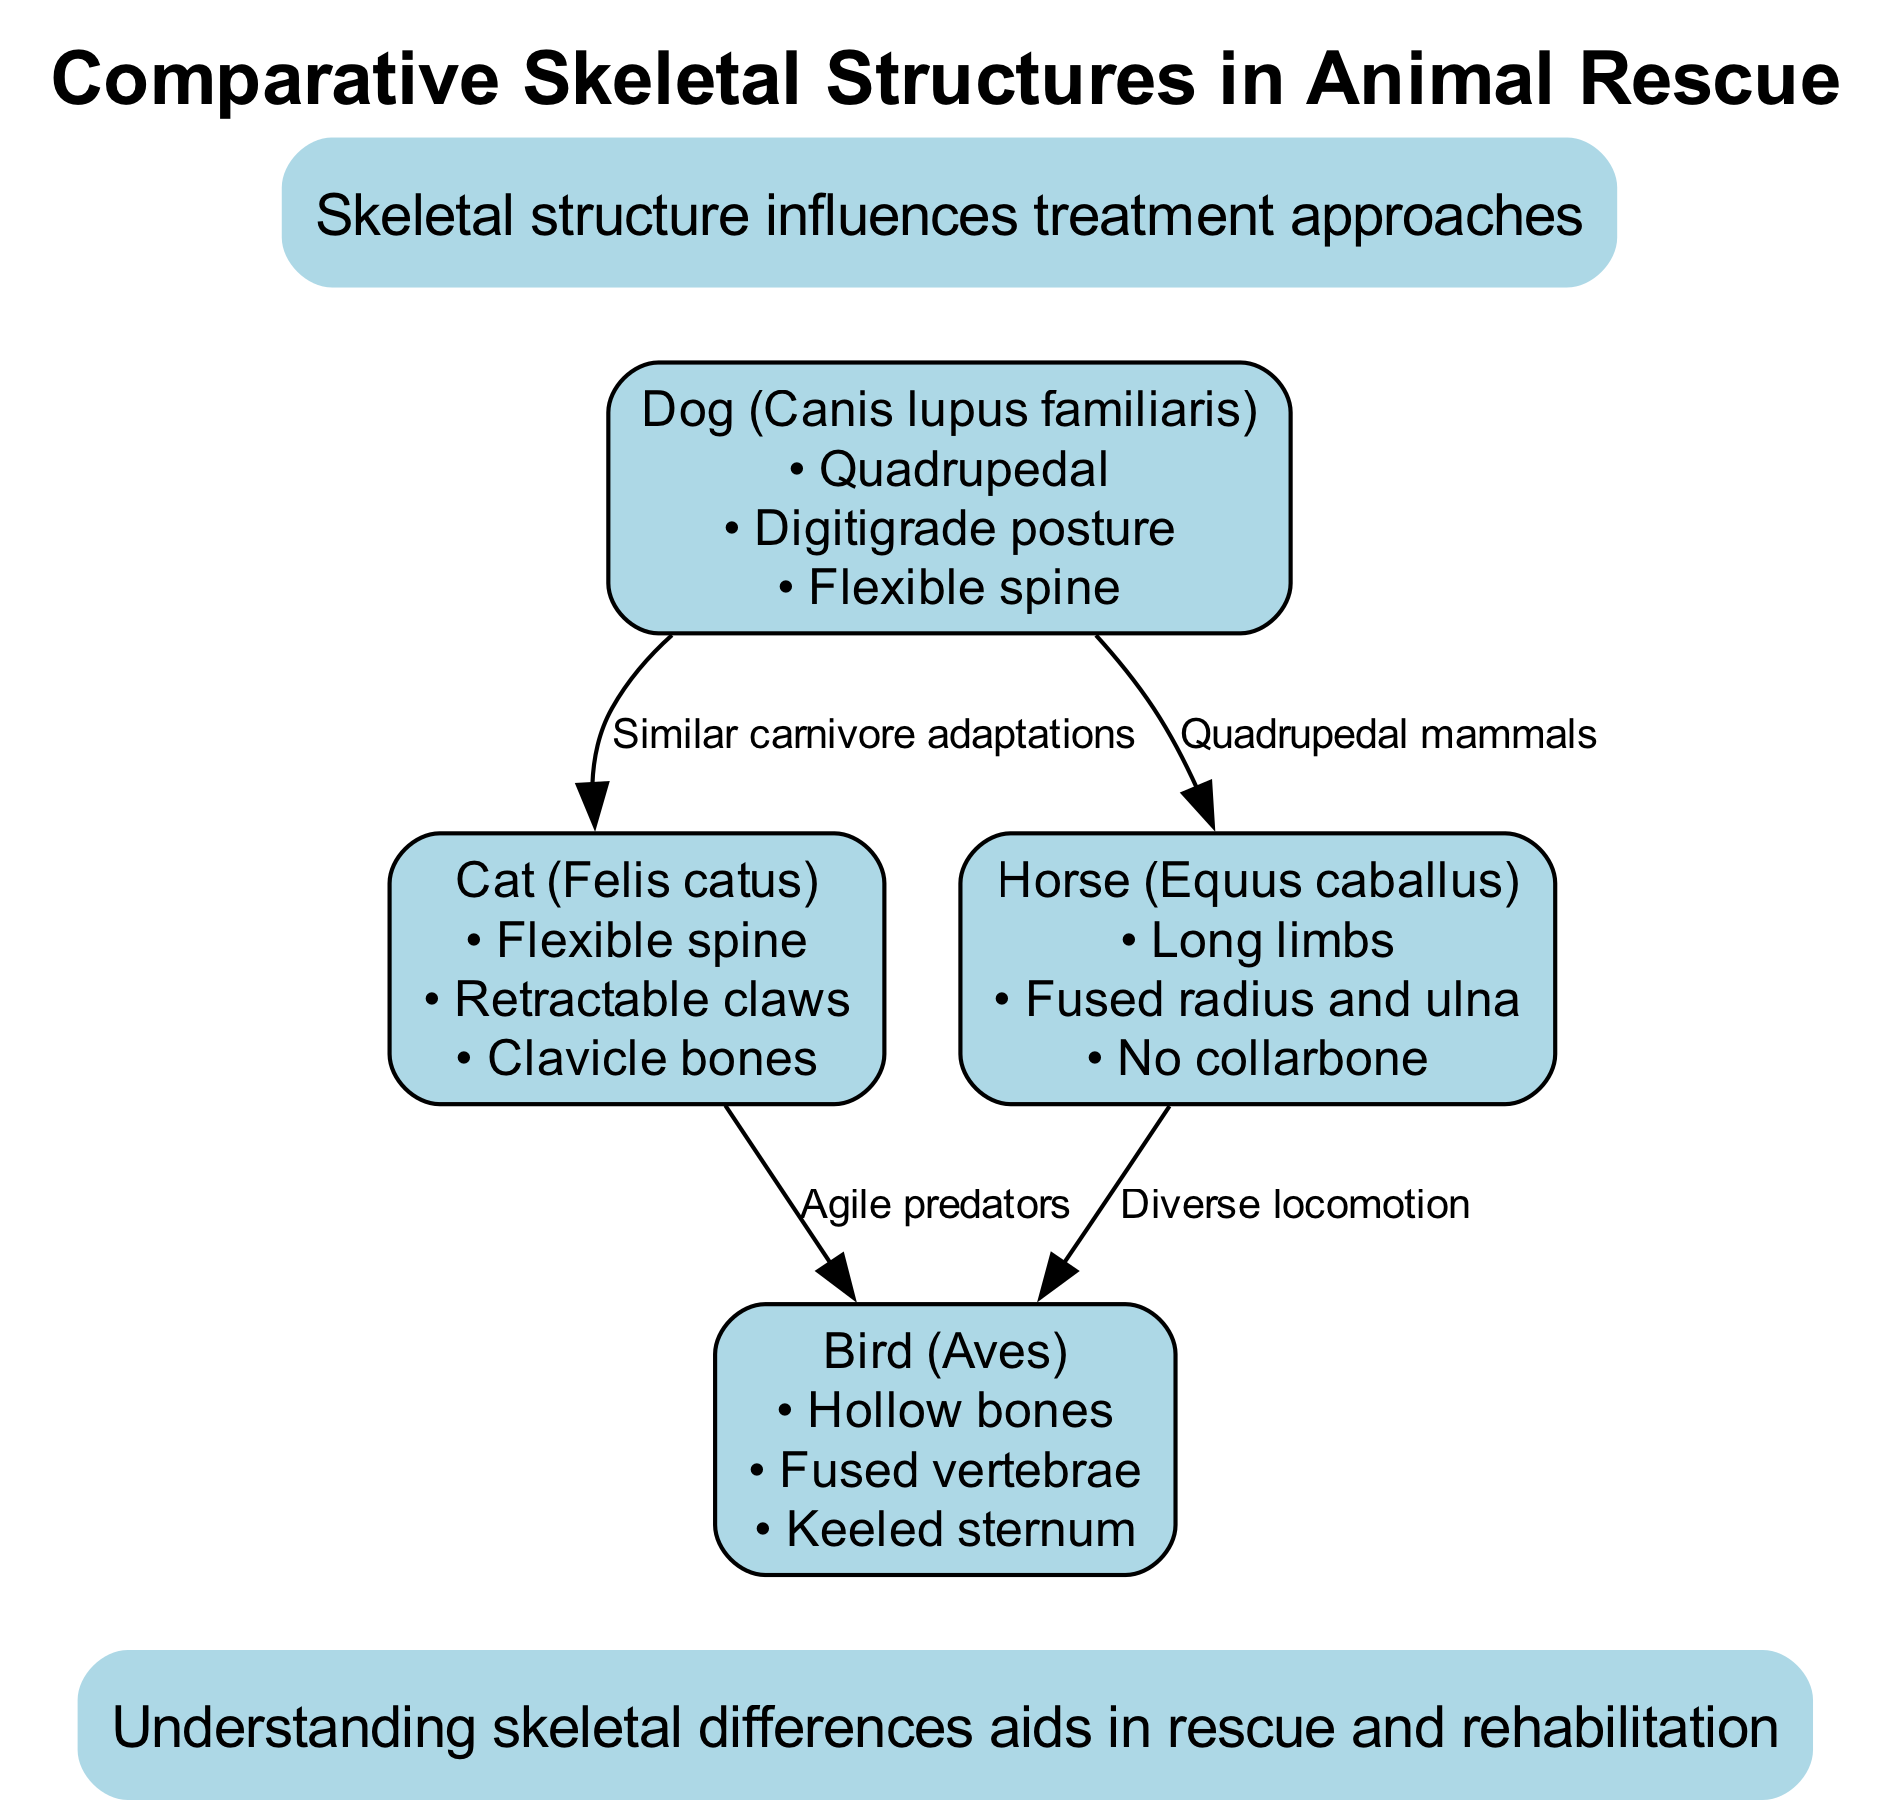What animal has a flexible spine and retractable claws? The question is asking for an animal that possesses both features. Looking at the diagram, the "Cat (Felis catus)" is listed with "Flexible spine" and "Retractable claws" as features. Therefore, the answer is Cat (Felis catus).
Answer: Cat (Felis catus) How many nodes are present in the diagram? The question asks for the count of distinct nodes shown in the diagram. Reviewing the data provided, there are four nodes representing different animals. Therefore, the answer is 4.
Answer: 4 What animal is characterized by hollow bones? The question seeks to identify an animal with that specific feature. Referring to the features listed, the "Bird (Aves)" is noted for having "Hollow bones." Thus, the answer is Bird (Aves).
Answer: Bird (Aves) Which two animals are connected by the label "Quadrupedal mammals"? This question requires identifying the animals that share the specified connection. The diagram indicates that the Dog (Canis lupus familiaris) and Horse (Equus caballus) are connected by that label. Hence, the answer is Dog (Canis lupus familiaris) and Horse (Equus caballus).
Answer: Dog (Canis lupus familiaris) and Horse (Equus caballus) What type of posture is associated with Dogs? The query requires a specific feature related to Dogs. According to the diagram, it states that Dogs have a "Digitigrade posture." Therefore, the answer is Digitigrade posture.
Answer: Digitigrade posture What is the relationship between Cats and Birds as indicated in the diagram? This question asks for the type of connection outlined between Cats and Birds. The diagram shows a connection labeled "Agile predators," indicating that both share this characteristic. Hence, the answer is Agile predators.
Answer: Agile predators How does skeletal structure influence animal treatment approaches? This question pertains to the information provided in the annotations at the top of the diagram, highlighting the concept that "Skeletal structure influences treatment approaches." The annotation directly supports the link between skeletal structure variations and differing treatment methods.
Answer: Skeletal structure influences treatment approaches Which animal has the feature of a fused radius and ulna? The question is looking for the specific animal known for that skeletal structure. Looking at the features listed, the "Horse (Equus caballus)" has "Fused radius and ulna." Thus, the answer is Horse (Equus caballus).
Answer: Horse (Equus caballus) 